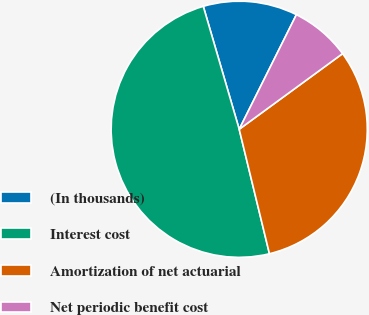Convert chart. <chart><loc_0><loc_0><loc_500><loc_500><pie_chart><fcel>(In thousands)<fcel>Interest cost<fcel>Amortization of net actuarial<fcel>Net periodic benefit cost<nl><fcel>11.89%<fcel>49.27%<fcel>31.26%<fcel>7.58%<nl></chart> 